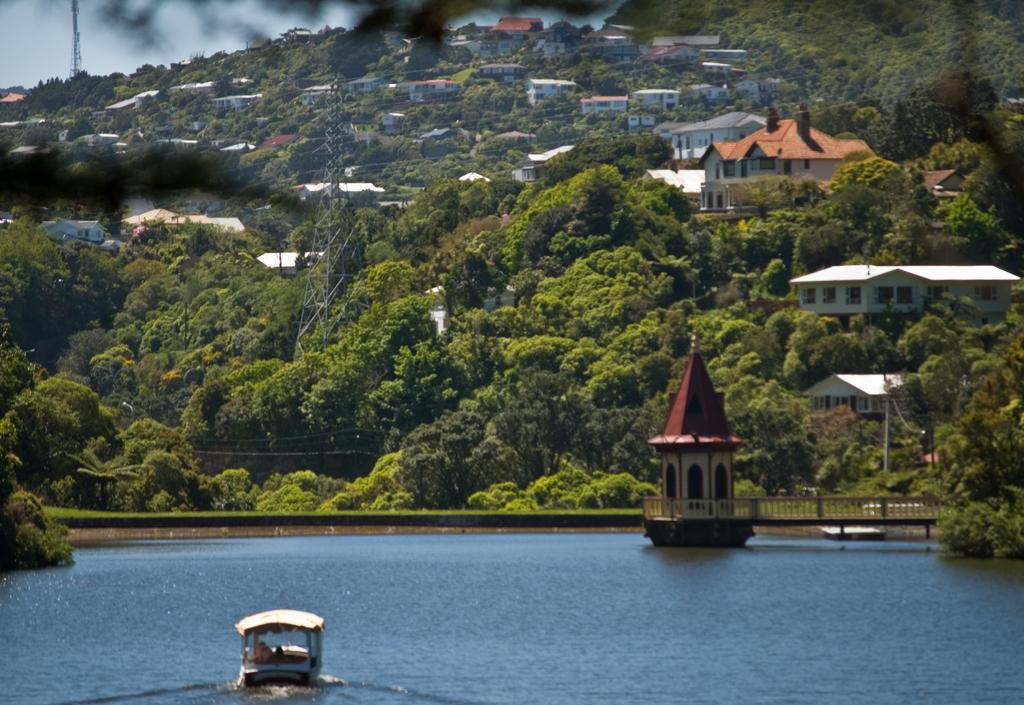What is the main feature of the image? The main feature of the image is water. What is floating on the water? There is a boat in the water. What type of vegetation can be seen in the image? There are plants and trees in the image. What structures are present in the image? There are towers, poles, and houses in the image. What part of the natural environment is visible in the image? The sky is visible in the image. How many babies are crying in the image? There are no babies or crying sounds present in the image. 